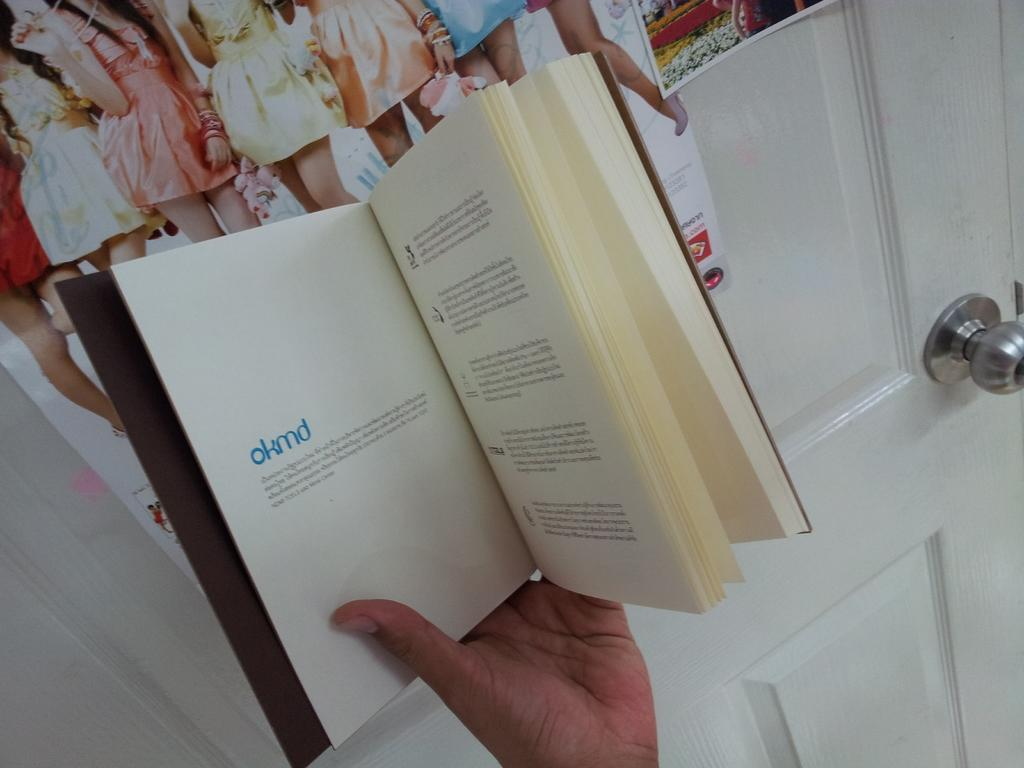Provide a one-sentence caption for the provided image. A book is opened to the first page which says okmd. 